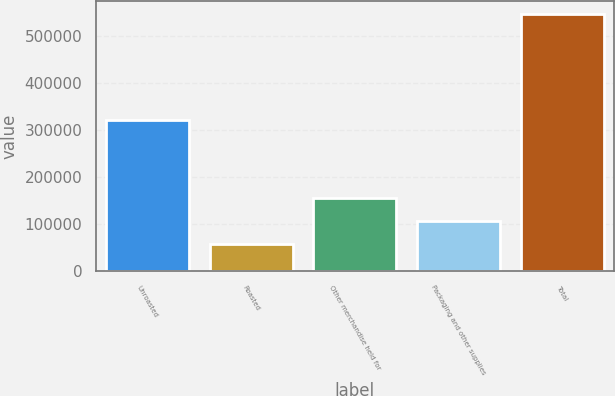<chart> <loc_0><loc_0><loc_500><loc_500><bar_chart><fcel>Unroasted<fcel>Roasted<fcel>Other merchandise held for<fcel>Packaging and other supplies<fcel>Total<nl><fcel>319745<fcel>56231<fcel>154245<fcel>105238<fcel>546299<nl></chart> 